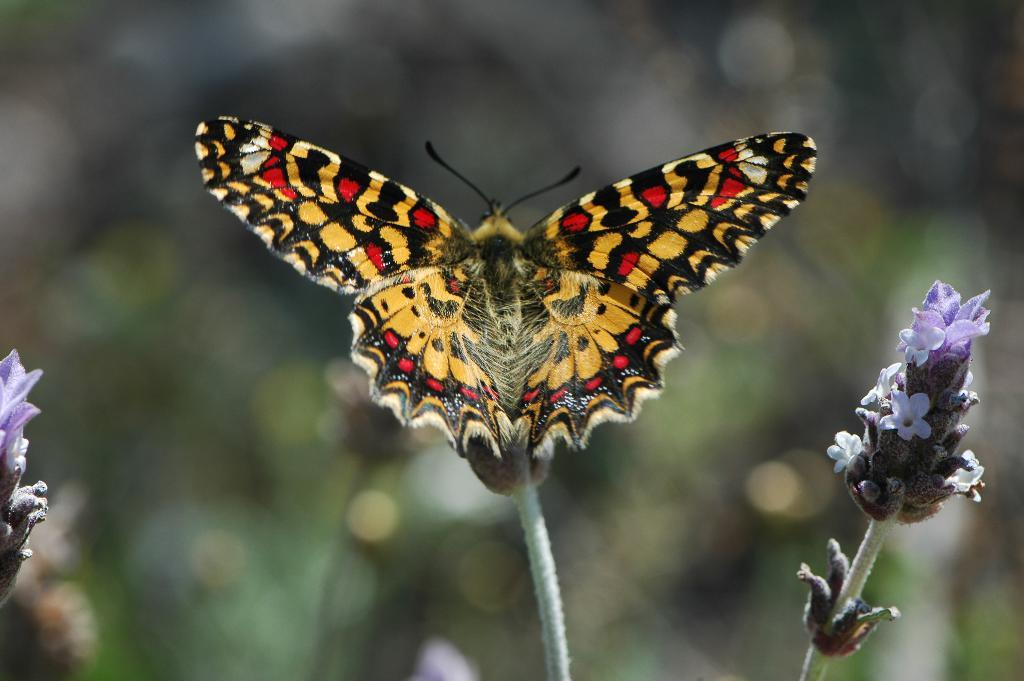What is the main subject of the image? There is a flower of a plant in the image. Is there anything else present in the image besides the flower? Yes, there is a butterfly above the flower in the image. How many bears can be seen interacting with the flower in the image? There are no bears present in the image. What type of finger is touching the butterfly in the image? There is no finger touching the butterfly in the image. 